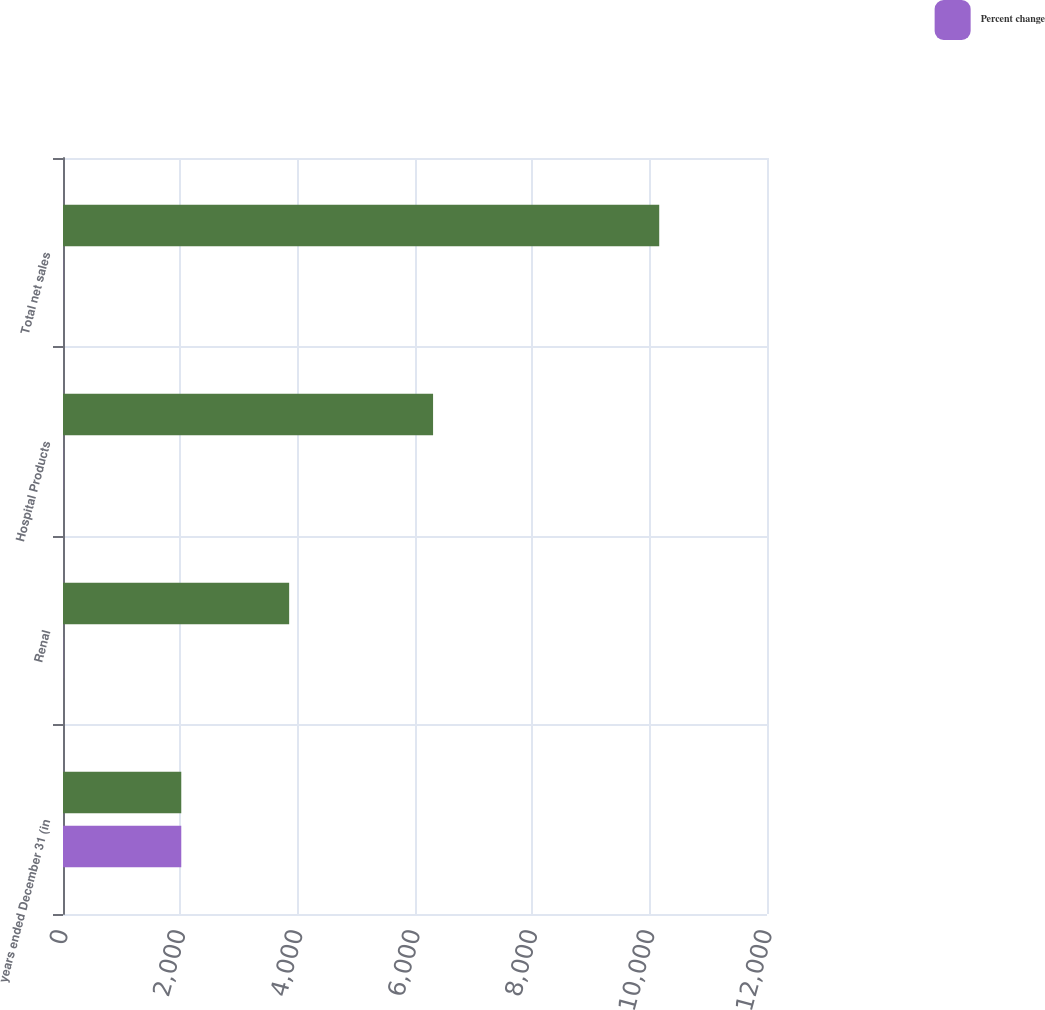Convert chart. <chart><loc_0><loc_0><loc_500><loc_500><stacked_bar_chart><ecel><fcel>years ended December 31 (in<fcel>Renal<fcel>Hospital Products<fcel>Total net sales<nl><fcel>nan<fcel>2016<fcel>3855<fcel>6308<fcel>10163<nl><fcel>Percent change<fcel>2016<fcel>2<fcel>2<fcel>2<nl></chart> 